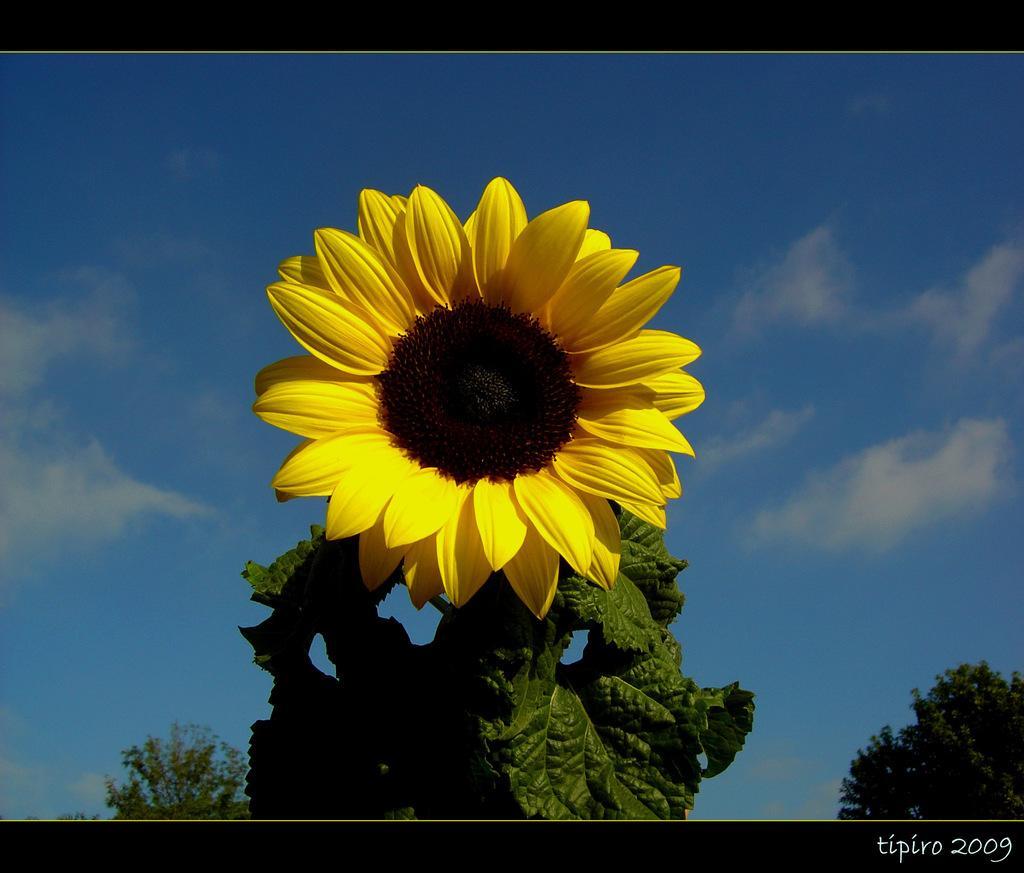In one or two sentences, can you explain what this image depicts? In this image, I can see a plant with a sunflower, which is yellow in color. These are the leaves. In the background, I can see the trees. These are the clouds in the sky. This is the watermark on the image. 